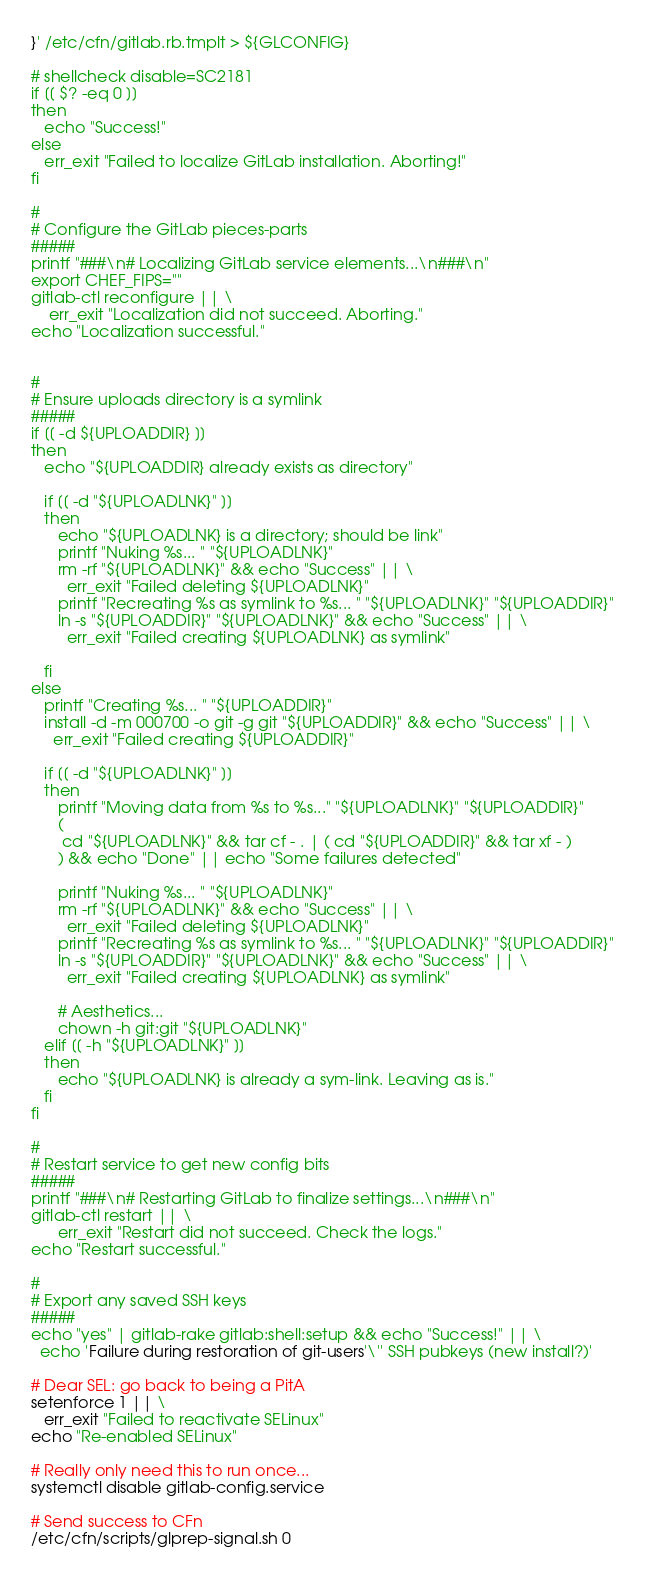<code> <loc_0><loc_0><loc_500><loc_500><_Bash_>}' /etc/cfn/gitlab.rb.tmplt > ${GLCONFIG}

# shellcheck disable=SC2181
if [[ $? -eq 0 ]]
then
   echo "Success!"
else
   err_exit "Failed to localize GitLab installation. Aborting!"
fi

#
# Configure the GitLab pieces-parts
#####
printf "###\n# Localizing GitLab service elements...\n###\n"
export CHEF_FIPS=""
gitlab-ctl reconfigure || \
    err_exit "Localization did not succeed. Aborting."
echo "Localization successful."


#
# Ensure uploads directory is a symlink
#####
if [[ -d ${UPLOADDIR} ]]
then
   echo "${UPLOADDIR} already exists as directory"

   if [[ -d "${UPLOADLNK}" ]]
   then
      echo "${UPLOADLNK} is a directory; should be link"
      printf "Nuking %s... " "${UPLOADLNK}"
      rm -rf "${UPLOADLNK}" && echo "Success" || \
        err_exit "Failed deleting ${UPLOADLNK}"
      printf "Recreating %s as symlink to %s... " "${UPLOADLNK}" "${UPLOADDIR}"
      ln -s "${UPLOADDIR}" "${UPLOADLNK}" && echo "Success" || \
        err_exit "Failed creating ${UPLOADLNK} as symlink"

   fi
else
   printf "Creating %s... " "${UPLOADDIR}"
   install -d -m 000700 -o git -g git "${UPLOADDIR}" && echo "Success" || \
     err_exit "Failed creating ${UPLOADDIR}"

   if [[ -d "${UPLOADLNK}" ]]
   then
      printf "Moving data from %s to %s..." "${UPLOADLNK}" "${UPLOADDIR}"
      (
       cd "${UPLOADLNK}" && tar cf - . | ( cd "${UPLOADDIR}" && tar xf - )
      ) && echo "Done" || echo "Some failures detected"

      printf "Nuking %s... " "${UPLOADLNK}"
      rm -rf "${UPLOADLNK}" && echo "Success" || \
        err_exit "Failed deleting ${UPLOADLNK}"
      printf "Recreating %s as symlink to %s... " "${UPLOADLNK}" "${UPLOADDIR}"
      ln -s "${UPLOADDIR}" "${UPLOADLNK}" && echo "Success" || \
        err_exit "Failed creating ${UPLOADLNK} as symlink"

      # Aesthetics...
      chown -h git:git "${UPLOADLNK}"
   elif [[ -h "${UPLOADLNK}" ]]
   then
      echo "${UPLOADLNK} is already a sym-link. Leaving as is."
   fi
fi

#
# Restart service to get new config bits
#####
printf "###\n# Restarting GitLab to finalize settings...\n###\n"
gitlab-ctl restart || \
      err_exit "Restart did not succeed. Check the logs."
echo "Restart successful."

#
# Export any saved SSH keys
#####
echo "yes" | gitlab-rake gitlab:shell:setup && echo "Success!" || \
  echo 'Failure during restoration of git-users'\'' SSH pubkeys (new install?)'

# Dear SEL: go back to being a PitA
setenforce 1 || \
   err_exit "Failed to reactivate SELinux"
echo "Re-enabled SELinux"

# Really only need this to run once...
systemctl disable gitlab-config.service

# Send success to CFn
/etc/cfn/scripts/glprep-signal.sh 0
</code> 